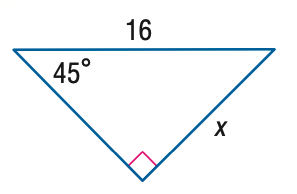Question: Find x.
Choices:
A. 8
B. 8 \sqrt { 2 }
C. 8 \sqrt { 3 }
D. 16
Answer with the letter. Answer: B 